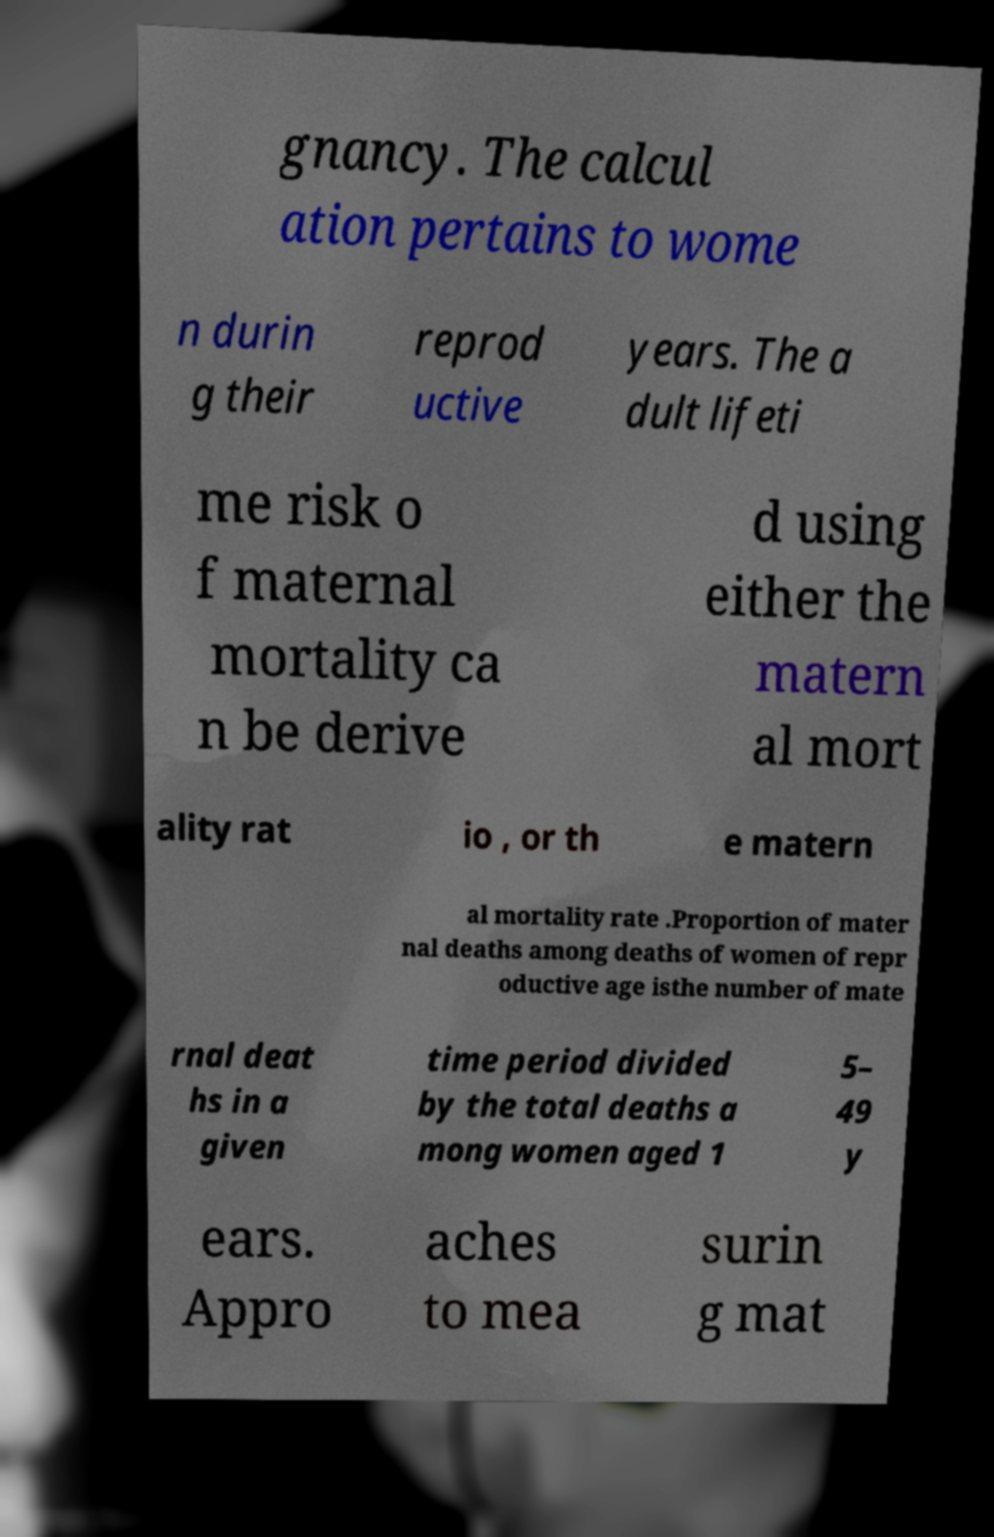Could you extract and type out the text from this image? gnancy. The calcul ation pertains to wome n durin g their reprod uctive years. The a dult lifeti me risk o f maternal mortality ca n be derive d using either the matern al mort ality rat io , or th e matern al mortality rate .Proportion of mater nal deaths among deaths of women of repr oductive age isthe number of mate rnal deat hs in a given time period divided by the total deaths a mong women aged 1 5– 49 y ears. Appro aches to mea surin g mat 